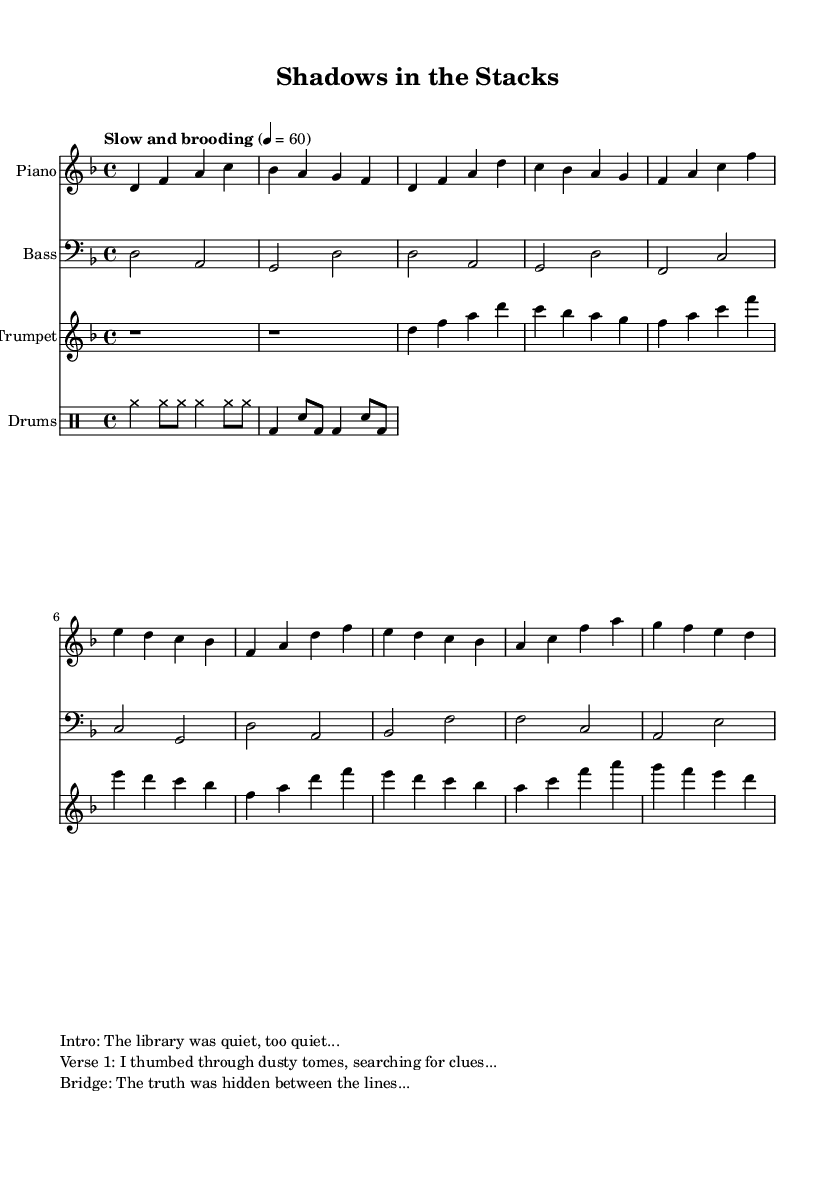What is the key signature of this music? The key signature is indicated by the sharp or flat symbols after the treble and bass clefs. In this case, the absence of sharps or flats before the notes indicates that the key signature is D minor.
Answer: D minor What is the time signature of this music? The time signature is found at the beginning of the sheet music, represented by the numbers above the staff. Here, the 4 over 4 indicates four beats per measure.
Answer: 4/4 What is the tempo marking of this music? The tempo marking is written below the clef with a specific term and a number indicating beats per minute. Here, "Slow and brooding" at 60 BPM shows the desired pace of the piece.
Answer: Slow and brooding How many instruments are featured in this piece? The score displays four distinct staves: piano, bass, trumpet, and drums. Counting these, we determine the total number of instruments.
Answer: Four What is the significance of the narration cues? The narration cues provide context to the music, reflecting on the storyline and mood of the piece. Each section of the narration corresponds to parts of the music, enhancing the overall narrative.
Answer: Storytelling Which instrument plays the introductory16 bars of the music? By examining the score, we see that it starts immediately with piano, which is indicated as the first staff in the score layout. Hence, it plays the introduction.
Answer: Piano What kind of musical genre does this piece represent? The combination of jazz elements along with dark, brooding motifs, followed by a detective-themed narration, places this piece firmly in the jazz-noir fusion genre.
Answer: Jazz-noir fusion 